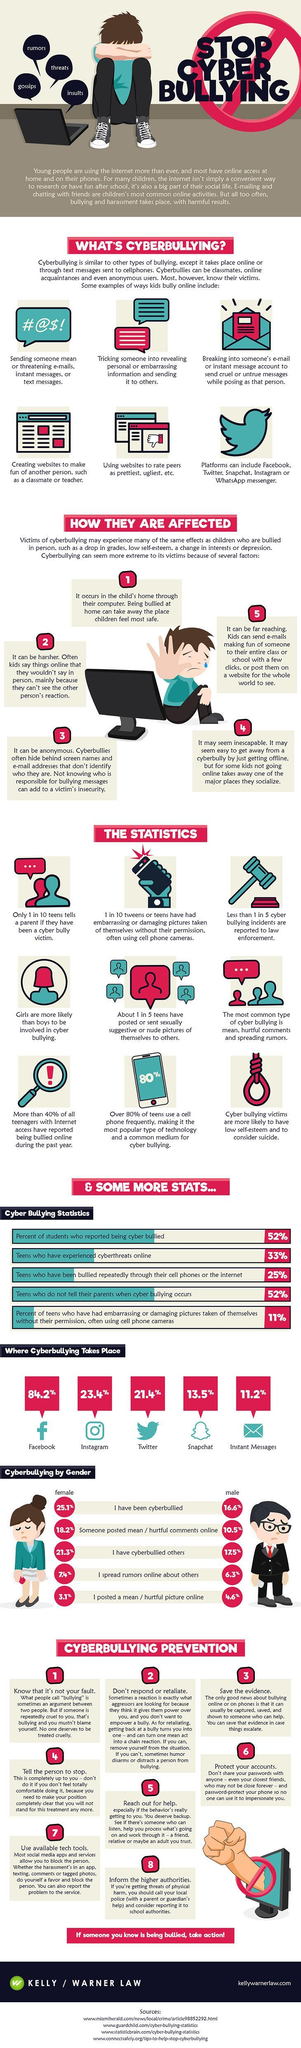Which gender faces higher percentages of cyberbullying in most forms?
Answer the question with a short phrase. female What is the colour of the instant messages icon- blue, red or pink? blue How many points should you follow to prevent cyberbullying as per the infographic? 8 How many points are given under how people are affected? 5 Which is the second most frequented place where cyberbullying takes place? Instagram 